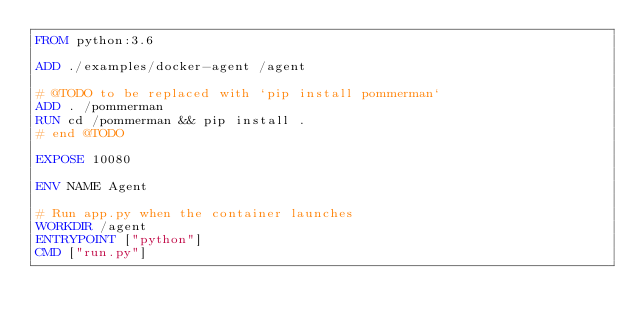<code> <loc_0><loc_0><loc_500><loc_500><_Dockerfile_>FROM python:3.6

ADD ./examples/docker-agent /agent

# @TODO to be replaced with `pip install pommerman`
ADD . /pommerman
RUN cd /pommerman && pip install .
# end @TODO

EXPOSE 10080

ENV NAME Agent

# Run app.py when the container launches
WORKDIR /agent
ENTRYPOINT ["python"]
CMD ["run.py"]</code> 